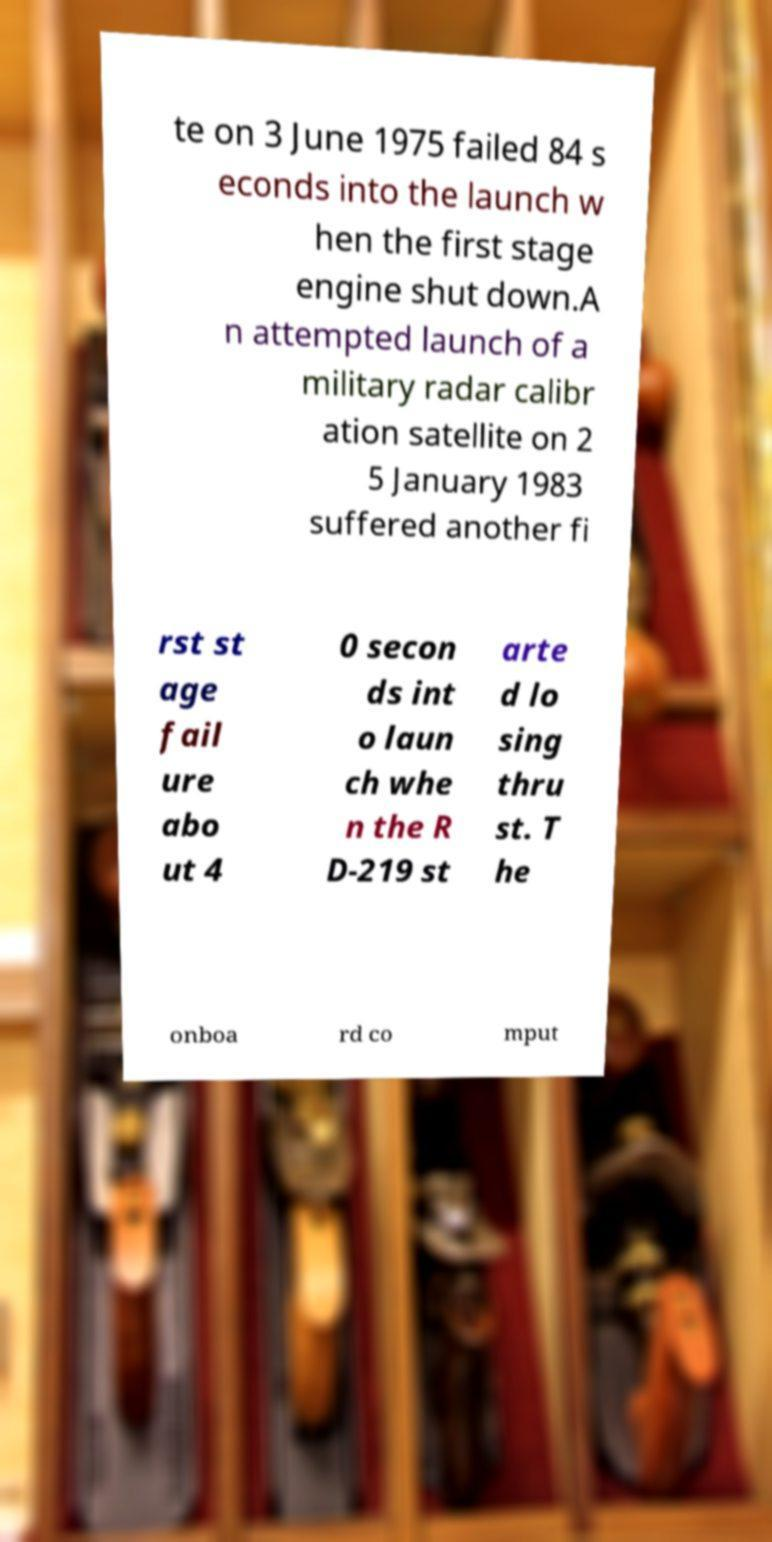Please identify and transcribe the text found in this image. te on 3 June 1975 failed 84 s econds into the launch w hen the first stage engine shut down.A n attempted launch of a military radar calibr ation satellite on 2 5 January 1983 suffered another fi rst st age fail ure abo ut 4 0 secon ds int o laun ch whe n the R D-219 st arte d lo sing thru st. T he onboa rd co mput 